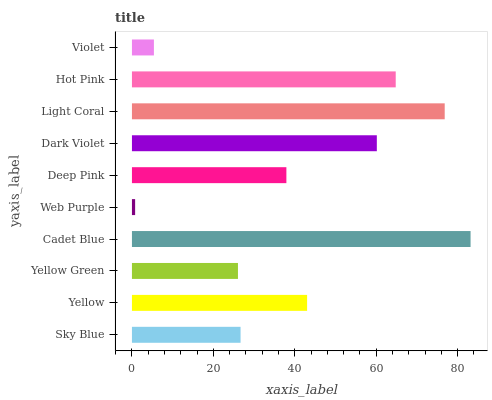Is Web Purple the minimum?
Answer yes or no. Yes. Is Cadet Blue the maximum?
Answer yes or no. Yes. Is Yellow the minimum?
Answer yes or no. No. Is Yellow the maximum?
Answer yes or no. No. Is Yellow greater than Sky Blue?
Answer yes or no. Yes. Is Sky Blue less than Yellow?
Answer yes or no. Yes. Is Sky Blue greater than Yellow?
Answer yes or no. No. Is Yellow less than Sky Blue?
Answer yes or no. No. Is Yellow the high median?
Answer yes or no. Yes. Is Deep Pink the low median?
Answer yes or no. Yes. Is Sky Blue the high median?
Answer yes or no. No. Is Web Purple the low median?
Answer yes or no. No. 